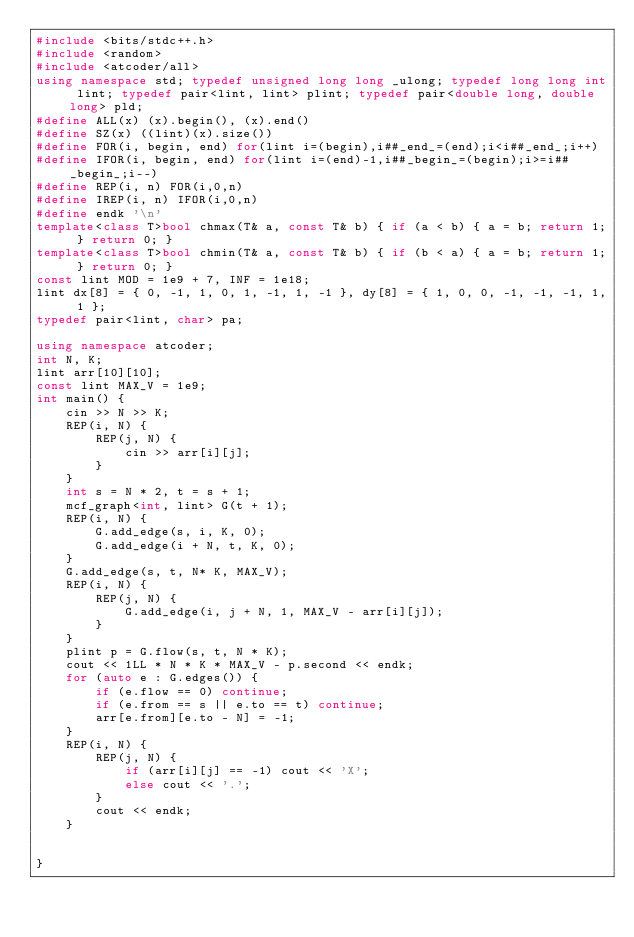Convert code to text. <code><loc_0><loc_0><loc_500><loc_500><_C++_>#include <bits/stdc++.h>
#include <random>
#include <atcoder/all>
using namespace std; typedef unsigned long long _ulong; typedef long long int lint; typedef pair<lint, lint> plint; typedef pair<double long, double long> pld;
#define ALL(x) (x).begin(), (x).end()
#define SZ(x) ((lint)(x).size())
#define FOR(i, begin, end) for(lint i=(begin),i##_end_=(end);i<i##_end_;i++)
#define IFOR(i, begin, end) for(lint i=(end)-1,i##_begin_=(begin);i>=i##_begin_;i--)
#define REP(i, n) FOR(i,0,n)
#define IREP(i, n) IFOR(i,0,n)
#define endk '\n'
template<class T>bool chmax(T& a, const T& b) { if (a < b) { a = b; return 1; } return 0; }
template<class T>bool chmin(T& a, const T& b) { if (b < a) { a = b; return 1; } return 0; }
const lint MOD = 1e9 + 7, INF = 1e18;
lint dx[8] = { 0, -1, 1, 0, 1, -1, 1, -1 }, dy[8] = { 1, 0, 0, -1, -1, -1, 1, 1 };
typedef pair<lint, char> pa;

using namespace atcoder;
int N, K;
lint arr[10][10];
const lint MAX_V = 1e9;
int main() {
	cin >> N >> K;
	REP(i, N) {
		REP(j, N) {
			cin >> arr[i][j];
		}
	}
	int s = N * 2, t = s + 1;
	mcf_graph<int, lint> G(t + 1);
	REP(i, N) {
		G.add_edge(s, i, K, 0);
		G.add_edge(i + N, t, K, 0);
	}
	G.add_edge(s, t, N* K, MAX_V);
	REP(i, N) {
		REP(j, N) {
			G.add_edge(i, j + N, 1, MAX_V - arr[i][j]);
		}
	}
	plint p = G.flow(s, t, N * K);
	cout << 1LL * N * K * MAX_V - p.second << endk;
	for (auto e : G.edges()) {
		if (e.flow == 0) continue;
		if (e.from == s || e.to == t) continue;
		arr[e.from][e.to - N] = -1;
	}
	REP(i, N) {
		REP(j, N) {
			if (arr[i][j] == -1) cout << 'X';
			else cout << '.';
		}
		cout << endk;
	}


}
</code> 